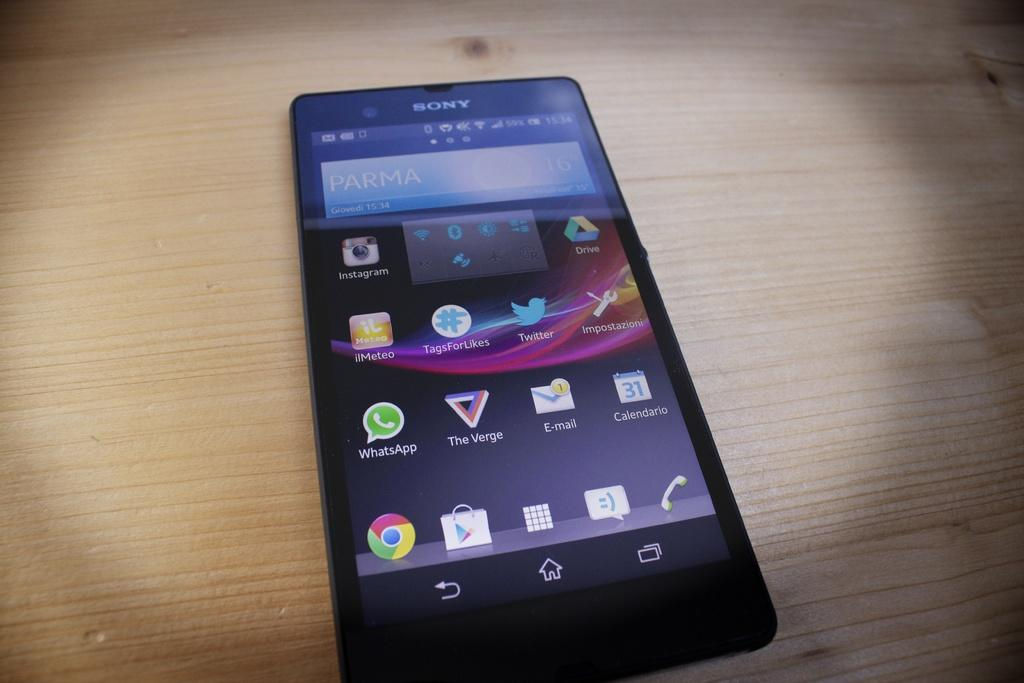<image>
Give a short and clear explanation of the subsequent image. a black sony phone that says 'parma' on the screen 